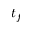<formula> <loc_0><loc_0><loc_500><loc_500>t _ { f }</formula> 